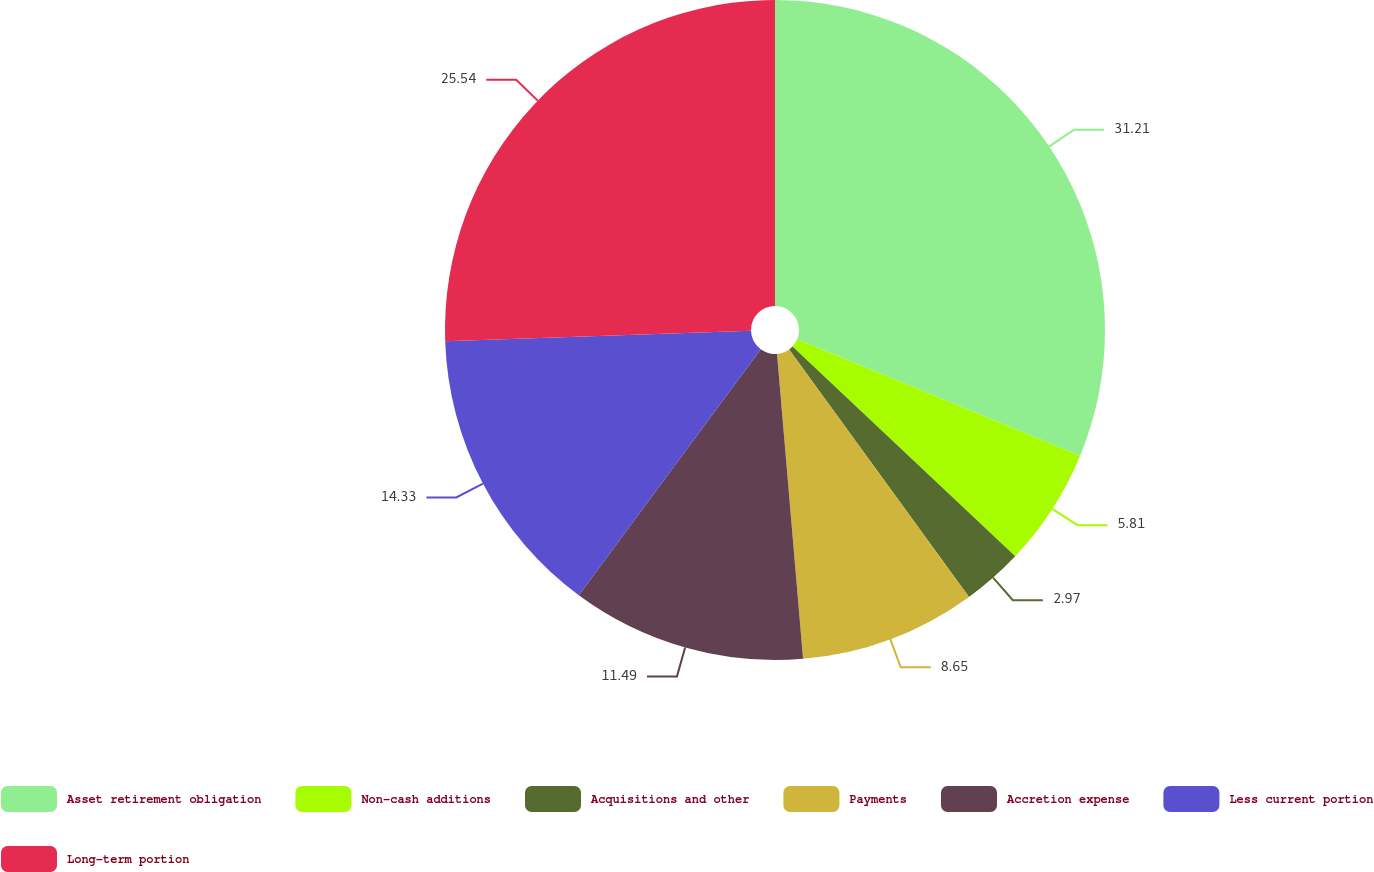Convert chart to OTSL. <chart><loc_0><loc_0><loc_500><loc_500><pie_chart><fcel>Asset retirement obligation<fcel>Non-cash additions<fcel>Acquisitions and other<fcel>Payments<fcel>Accretion expense<fcel>Less current portion<fcel>Long-term portion<nl><fcel>31.22%<fcel>5.81%<fcel>2.97%<fcel>8.65%<fcel>11.49%<fcel>14.33%<fcel>25.54%<nl></chart> 